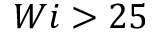Convert formula to latex. <formula><loc_0><loc_0><loc_500><loc_500>W i > 2 5</formula> 